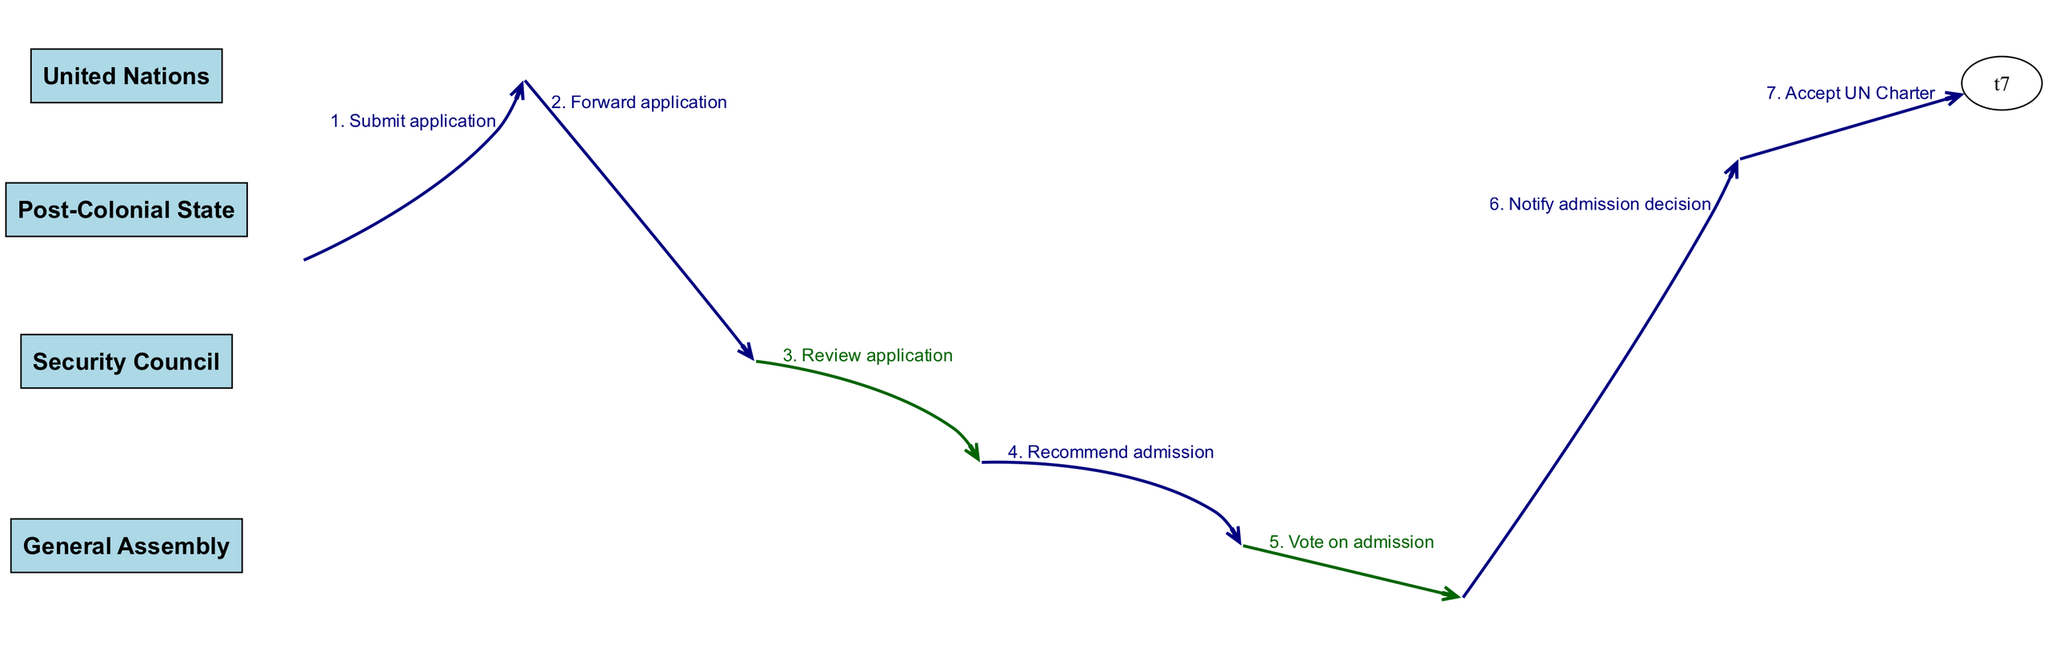What is the first action taken by the Post-Colonial State? The first action listed in the sequence is the "Submit application" by the Post-Colonial State. This is the initial step of the entire process and is represented as the first entry in the sequence.
Answer: Submit application How many actors are involved in the diagram? The diagram lists four distinct actors: Post-Colonial State, United Nations, Security Council, and General Assembly. Counting each actor gives a total of four.
Answer: 4 What is the final action taken by the Post-Colonial State? The final action noted in the sequence is "Accept UN Charter," which concludes the process for the Post-Colonial State after the admission decision from the General Assembly.
Answer: Accept UN Charter Which entity reviews the application after it's submitted? According to the sequence, after the Post-Colonial State submits the application, it is forwarded to the Security Council, which is responsible for reviewing the application before making a recommendation.
Answer: Security Council How many steps are there until the Post-Colonial State is notified of the admission decision? To find the number of steps until the notification, we count from the submission of the application to the notification, which involves five distinct actions before receiving the notification. Therefore, there are five steps.
Answer: 5 What happens after the Security Council reviews the application? Following the review of the application, the Security Council takes action to recommend admission to the General Assembly, which is an essential step in the admission process.
Answer: Recommend admission What type of edge connects the General Assembly to itself during the voting process? The edge connecting the General Assembly to itself during the voting is a self-loop, indicating that the same entity is performing the action of voting on admission. It showcases that the voting process is an internal action.
Answer: Self-loop Which entity is notified of the admission decision? The diagram indicates that the General Assembly notifies the Post-Colonial State of the admission decision after the voting process is completed. This underscores the communicative aspect of the process.
Answer: Post-Colonial State 